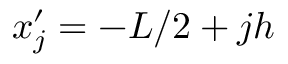<formula> <loc_0><loc_0><loc_500><loc_500>x _ { j } ^ { \prime } = - L / 2 + j h</formula> 